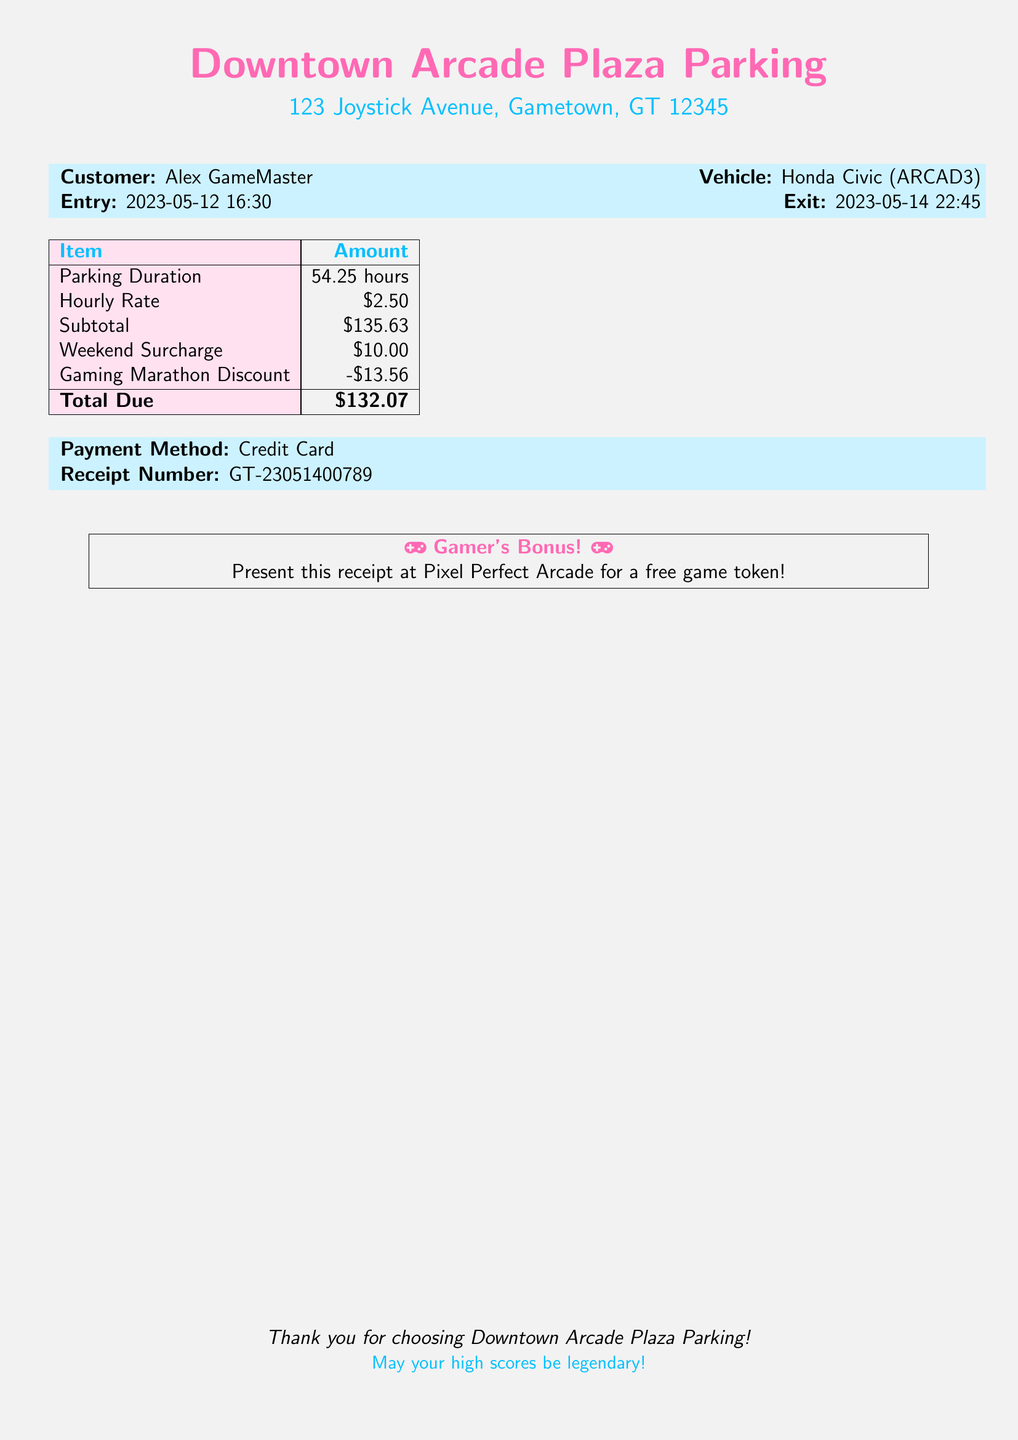What is the customer name? The document states that the customer is Alex GameMaster.
Answer: Alex GameMaster What is the vehicle type? The bill mentions the vehicle type as Honda Civic.
Answer: Honda Civic What is the total amount due? The total amount due on the bill is listed as $132.07.
Answer: $132.07 How many hours was the parking duration? The document indicates a parking duration of 54.25 hours.
Answer: 54.25 hours What was the weekend surcharge? The bill includes a weekend surcharge amount of $10.00.
Answer: $10.00 What discount is applied for the gaming marathon? The discount for the gaming marathon is noted as -$13.56.
Answer: -$13.56 When did the customer enter the parking garage? The entry date and time for the parking garage is listed as 2023-05-12 16:30.
Answer: 2023-05-12 16:30 When did the customer exit the parking garage? The exit date and time is shown as 2023-05-14 22:45.
Answer: 2023-05-14 22:45 What is the receipt number? The receipt number provided in the document is GT-23051400789.
Answer: GT-23051400789 